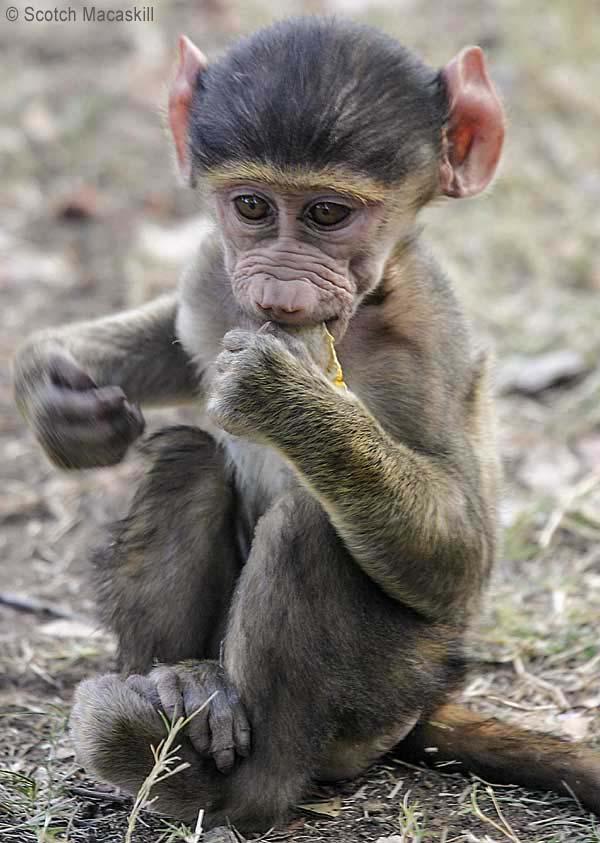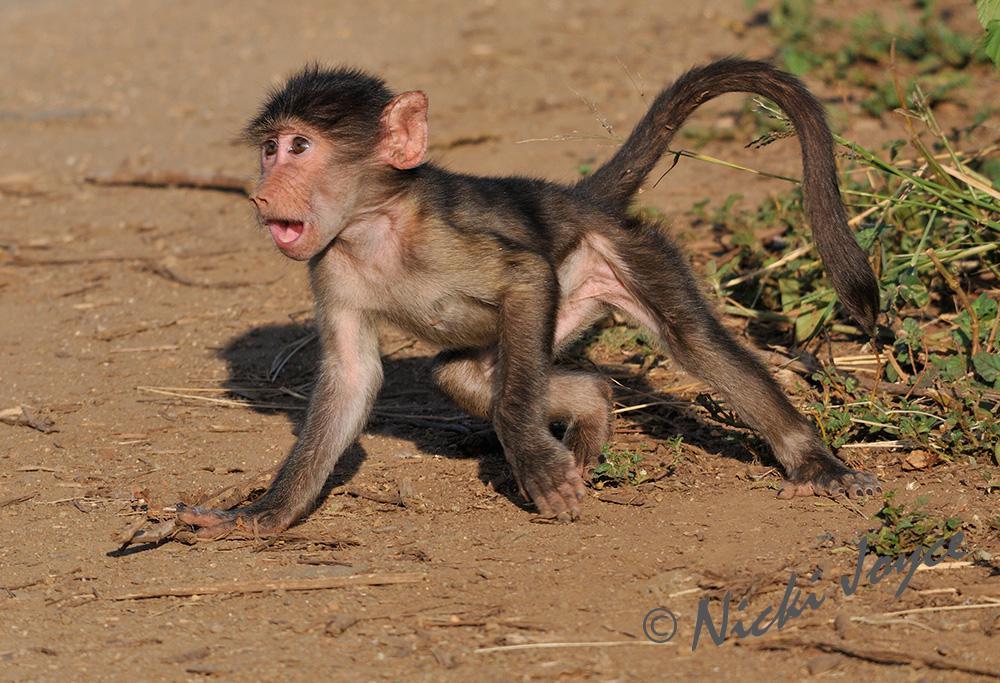The first image is the image on the left, the second image is the image on the right. For the images shown, is this caption "In the image on the left, a mother carries her baby." true? Answer yes or no. No. The first image is the image on the left, the second image is the image on the right. For the images displayed, is the sentence "There are three monkeys." factually correct? Answer yes or no. No. 